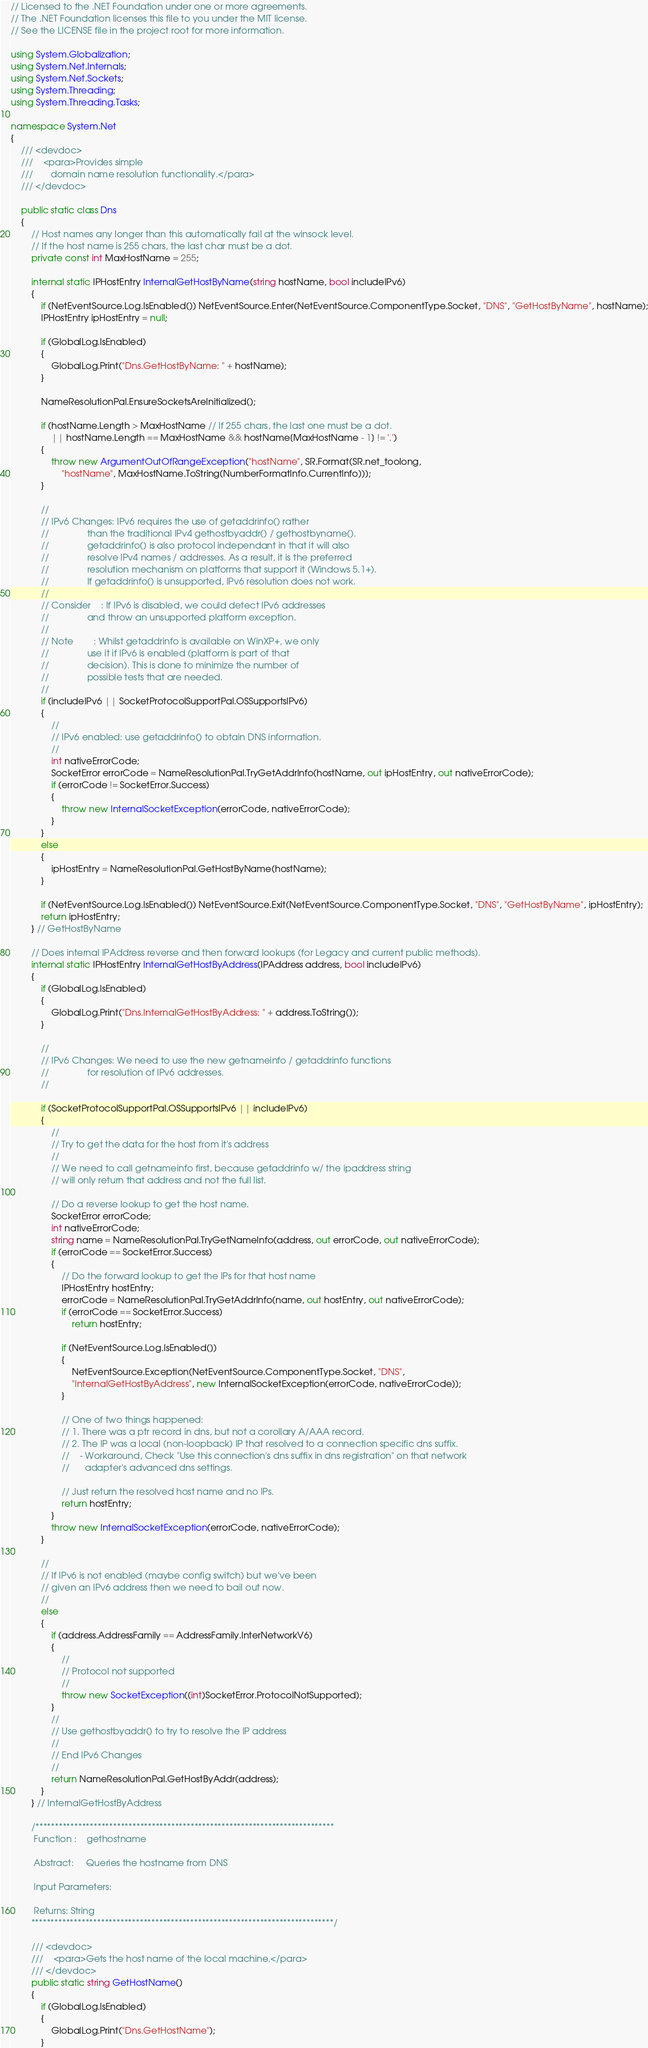Convert code to text. <code><loc_0><loc_0><loc_500><loc_500><_C#_>// Licensed to the .NET Foundation under one or more agreements.
// The .NET Foundation licenses this file to you under the MIT license.
// See the LICENSE file in the project root for more information.

using System.Globalization;
using System.Net.Internals;
using System.Net.Sockets;
using System.Threading;
using System.Threading.Tasks;

namespace System.Net
{
    /// <devdoc>
    ///    <para>Provides simple
    ///       domain name resolution functionality.</para>
    /// </devdoc>

    public static class Dns
    {
        // Host names any longer than this automatically fail at the winsock level.
        // If the host name is 255 chars, the last char must be a dot.
        private const int MaxHostName = 255;

        internal static IPHostEntry InternalGetHostByName(string hostName, bool includeIPv6)
        {
            if (NetEventSource.Log.IsEnabled()) NetEventSource.Enter(NetEventSource.ComponentType.Socket, "DNS", "GetHostByName", hostName);
            IPHostEntry ipHostEntry = null;

            if (GlobalLog.IsEnabled)
            {
                GlobalLog.Print("Dns.GetHostByName: " + hostName);
            }

            NameResolutionPal.EnsureSocketsAreInitialized();

            if (hostName.Length > MaxHostName // If 255 chars, the last one must be a dot.
                || hostName.Length == MaxHostName && hostName[MaxHostName - 1] != '.')
            {
                throw new ArgumentOutOfRangeException("hostName", SR.Format(SR.net_toolong,
                    "hostName", MaxHostName.ToString(NumberFormatInfo.CurrentInfo)));
            }

            //
            // IPv6 Changes: IPv6 requires the use of getaddrinfo() rather
            //               than the traditional IPv4 gethostbyaddr() / gethostbyname().
            //               getaddrinfo() is also protocol independant in that it will also
            //               resolve IPv4 names / addresses. As a result, it is the preferred
            //               resolution mechanism on platforms that support it (Windows 5.1+).
            //               If getaddrinfo() is unsupported, IPv6 resolution does not work.
            //
            // Consider    : If IPv6 is disabled, we could detect IPv6 addresses
            //               and throw an unsupported platform exception.
            //
            // Note        : Whilst getaddrinfo is available on WinXP+, we only
            //               use it if IPv6 is enabled (platform is part of that
            //               decision). This is done to minimize the number of
            //               possible tests that are needed.
            //
            if (includeIPv6 || SocketProtocolSupportPal.OSSupportsIPv6)
            {
                //
                // IPv6 enabled: use getaddrinfo() to obtain DNS information.
                //
                int nativeErrorCode;
                SocketError errorCode = NameResolutionPal.TryGetAddrInfo(hostName, out ipHostEntry, out nativeErrorCode);
                if (errorCode != SocketError.Success)
                {
                    throw new InternalSocketException(errorCode, nativeErrorCode);
                }
            }
            else
            {
                ipHostEntry = NameResolutionPal.GetHostByName(hostName);
            }

            if (NetEventSource.Log.IsEnabled()) NetEventSource.Exit(NetEventSource.ComponentType.Socket, "DNS", "GetHostByName", ipHostEntry);
            return ipHostEntry;
        } // GetHostByName

        // Does internal IPAddress reverse and then forward lookups (for Legacy and current public methods).
        internal static IPHostEntry InternalGetHostByAddress(IPAddress address, bool includeIPv6)
        {
            if (GlobalLog.IsEnabled)
            {
                GlobalLog.Print("Dns.InternalGetHostByAddress: " + address.ToString());
            }
            
            //
            // IPv6 Changes: We need to use the new getnameinfo / getaddrinfo functions
            //               for resolution of IPv6 addresses.
            //

            if (SocketProtocolSupportPal.OSSupportsIPv6 || includeIPv6)
            {
                //
                // Try to get the data for the host from it's address
                //
                // We need to call getnameinfo first, because getaddrinfo w/ the ipaddress string
                // will only return that address and not the full list.

                // Do a reverse lookup to get the host name.
                SocketError errorCode;
                int nativeErrorCode;
                string name = NameResolutionPal.TryGetNameInfo(address, out errorCode, out nativeErrorCode);
                if (errorCode == SocketError.Success)
                {
                    // Do the forward lookup to get the IPs for that host name
                    IPHostEntry hostEntry;
                    errorCode = NameResolutionPal.TryGetAddrInfo(name, out hostEntry, out nativeErrorCode);
                    if (errorCode == SocketError.Success)
                        return hostEntry;

                    if (NetEventSource.Log.IsEnabled())
                    {
                        NetEventSource.Exception(NetEventSource.ComponentType.Socket, "DNS",
                        "InternalGetHostByAddress", new InternalSocketException(errorCode, nativeErrorCode));
                    }

                    // One of two things happened:
                    // 1. There was a ptr record in dns, but not a corollary A/AAA record.
                    // 2. The IP was a local (non-loopback) IP that resolved to a connection specific dns suffix.
                    //    - Workaround, Check "Use this connection's dns suffix in dns registration" on that network
                    //      adapter's advanced dns settings.

                    // Just return the resolved host name and no IPs.
                    return hostEntry;
                }
                throw new InternalSocketException(errorCode, nativeErrorCode);
            }

            //
            // If IPv6 is not enabled (maybe config switch) but we've been
            // given an IPv6 address then we need to bail out now.
            //
            else
            {
                if (address.AddressFamily == AddressFamily.InterNetworkV6)
                {
                    //
                    // Protocol not supported
                    //
                    throw new SocketException((int)SocketError.ProtocolNotSupported);
                }
                //
                // Use gethostbyaddr() to try to resolve the IP address
                //
                // End IPv6 Changes
                //
                return NameResolutionPal.GetHostByAddr(address);
            }
        } // InternalGetHostByAddress

        /*****************************************************************************
         Function :    gethostname

         Abstract:     Queries the hostname from DNS

         Input Parameters:

         Returns: String
        ******************************************************************************/

        /// <devdoc>
        ///    <para>Gets the host name of the local machine.</para>
        /// </devdoc>
        public static string GetHostName()
        {
            if (GlobalLog.IsEnabled)
            {
                GlobalLog.Print("Dns.GetHostName");
            }
</code> 